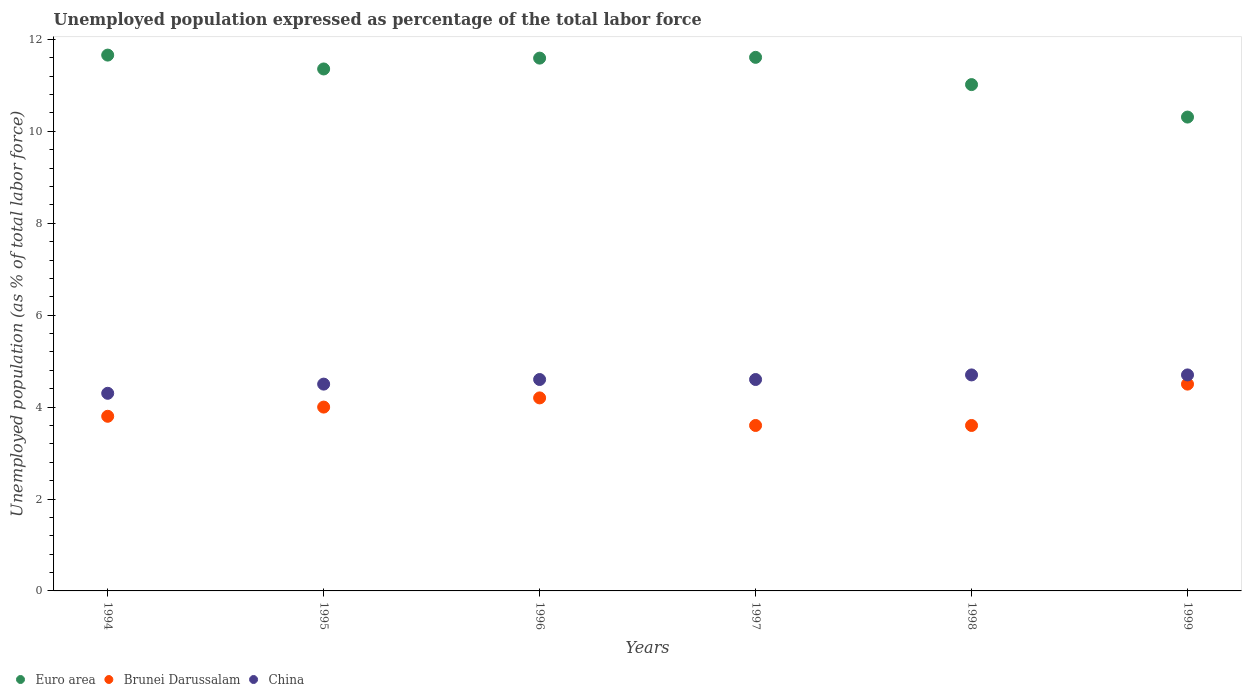How many different coloured dotlines are there?
Your response must be concise. 3. Is the number of dotlines equal to the number of legend labels?
Your answer should be compact. Yes. What is the unemployment in in Euro area in 1999?
Your response must be concise. 10.31. Across all years, what is the minimum unemployment in in Euro area?
Offer a terse response. 10.31. In which year was the unemployment in in Euro area maximum?
Offer a terse response. 1994. What is the total unemployment in in Brunei Darussalam in the graph?
Your answer should be compact. 23.7. What is the difference between the unemployment in in Euro area in 1994 and that in 1999?
Make the answer very short. 1.35. What is the difference between the unemployment in in China in 1995 and the unemployment in in Brunei Darussalam in 1997?
Give a very brief answer. 0.9. What is the average unemployment in in Euro area per year?
Your response must be concise. 11.26. In how many years, is the unemployment in in Euro area greater than 1.6 %?
Make the answer very short. 6. What is the ratio of the unemployment in in Euro area in 1996 to that in 1997?
Provide a succinct answer. 1. Is the unemployment in in Euro area in 1994 less than that in 1996?
Ensure brevity in your answer.  No. Is the difference between the unemployment in in Brunei Darussalam in 1995 and 1996 greater than the difference between the unemployment in in China in 1995 and 1996?
Ensure brevity in your answer.  No. What is the difference between the highest and the second highest unemployment in in Euro area?
Give a very brief answer. 0.05. What is the difference between the highest and the lowest unemployment in in Brunei Darussalam?
Keep it short and to the point. 0.9. In how many years, is the unemployment in in Brunei Darussalam greater than the average unemployment in in Brunei Darussalam taken over all years?
Your response must be concise. 3. Is the sum of the unemployment in in China in 1994 and 1995 greater than the maximum unemployment in in Brunei Darussalam across all years?
Your answer should be compact. Yes. Is it the case that in every year, the sum of the unemployment in in Euro area and unemployment in in China  is greater than the unemployment in in Brunei Darussalam?
Your answer should be compact. Yes. Does the unemployment in in China monotonically increase over the years?
Offer a terse response. No. How many years are there in the graph?
Your response must be concise. 6. Does the graph contain grids?
Ensure brevity in your answer.  No. Where does the legend appear in the graph?
Keep it short and to the point. Bottom left. How many legend labels are there?
Keep it short and to the point. 3. What is the title of the graph?
Your answer should be very brief. Unemployed population expressed as percentage of the total labor force. What is the label or title of the X-axis?
Offer a terse response. Years. What is the label or title of the Y-axis?
Provide a succinct answer. Unemployed population (as % of total labor force). What is the Unemployed population (as % of total labor force) in Euro area in 1994?
Provide a succinct answer. 11.66. What is the Unemployed population (as % of total labor force) of Brunei Darussalam in 1994?
Keep it short and to the point. 3.8. What is the Unemployed population (as % of total labor force) in China in 1994?
Make the answer very short. 4.3. What is the Unemployed population (as % of total labor force) of Euro area in 1995?
Your answer should be compact. 11.36. What is the Unemployed population (as % of total labor force) in Brunei Darussalam in 1995?
Offer a terse response. 4. What is the Unemployed population (as % of total labor force) in Euro area in 1996?
Provide a succinct answer. 11.59. What is the Unemployed population (as % of total labor force) of Brunei Darussalam in 1996?
Your answer should be compact. 4.2. What is the Unemployed population (as % of total labor force) of China in 1996?
Offer a very short reply. 4.6. What is the Unemployed population (as % of total labor force) of Euro area in 1997?
Make the answer very short. 11.61. What is the Unemployed population (as % of total labor force) in Brunei Darussalam in 1997?
Provide a short and direct response. 3.6. What is the Unemployed population (as % of total labor force) in China in 1997?
Make the answer very short. 4.6. What is the Unemployed population (as % of total labor force) in Euro area in 1998?
Ensure brevity in your answer.  11.02. What is the Unemployed population (as % of total labor force) of Brunei Darussalam in 1998?
Give a very brief answer. 3.6. What is the Unemployed population (as % of total labor force) in China in 1998?
Your answer should be compact. 4.7. What is the Unemployed population (as % of total labor force) of Euro area in 1999?
Keep it short and to the point. 10.31. What is the Unemployed population (as % of total labor force) of Brunei Darussalam in 1999?
Your answer should be very brief. 4.5. What is the Unemployed population (as % of total labor force) of China in 1999?
Offer a very short reply. 4.7. Across all years, what is the maximum Unemployed population (as % of total labor force) in Euro area?
Ensure brevity in your answer.  11.66. Across all years, what is the maximum Unemployed population (as % of total labor force) of Brunei Darussalam?
Offer a very short reply. 4.5. Across all years, what is the maximum Unemployed population (as % of total labor force) of China?
Your answer should be compact. 4.7. Across all years, what is the minimum Unemployed population (as % of total labor force) in Euro area?
Ensure brevity in your answer.  10.31. Across all years, what is the minimum Unemployed population (as % of total labor force) of Brunei Darussalam?
Keep it short and to the point. 3.6. Across all years, what is the minimum Unemployed population (as % of total labor force) in China?
Provide a succinct answer. 4.3. What is the total Unemployed population (as % of total labor force) of Euro area in the graph?
Provide a succinct answer. 67.55. What is the total Unemployed population (as % of total labor force) in Brunei Darussalam in the graph?
Your answer should be very brief. 23.7. What is the total Unemployed population (as % of total labor force) of China in the graph?
Offer a very short reply. 27.4. What is the difference between the Unemployed population (as % of total labor force) of Euro area in 1994 and that in 1995?
Your answer should be compact. 0.3. What is the difference between the Unemployed population (as % of total labor force) of Brunei Darussalam in 1994 and that in 1995?
Keep it short and to the point. -0.2. What is the difference between the Unemployed population (as % of total labor force) of China in 1994 and that in 1995?
Make the answer very short. -0.2. What is the difference between the Unemployed population (as % of total labor force) of Euro area in 1994 and that in 1996?
Provide a short and direct response. 0.07. What is the difference between the Unemployed population (as % of total labor force) in Brunei Darussalam in 1994 and that in 1996?
Provide a succinct answer. -0.4. What is the difference between the Unemployed population (as % of total labor force) in China in 1994 and that in 1996?
Keep it short and to the point. -0.3. What is the difference between the Unemployed population (as % of total labor force) in Euro area in 1994 and that in 1997?
Make the answer very short. 0.05. What is the difference between the Unemployed population (as % of total labor force) of Brunei Darussalam in 1994 and that in 1997?
Your answer should be compact. 0.2. What is the difference between the Unemployed population (as % of total labor force) of China in 1994 and that in 1997?
Your answer should be compact. -0.3. What is the difference between the Unemployed population (as % of total labor force) of Euro area in 1994 and that in 1998?
Make the answer very short. 0.64. What is the difference between the Unemployed population (as % of total labor force) of Brunei Darussalam in 1994 and that in 1998?
Keep it short and to the point. 0.2. What is the difference between the Unemployed population (as % of total labor force) in Euro area in 1994 and that in 1999?
Provide a short and direct response. 1.35. What is the difference between the Unemployed population (as % of total labor force) in Euro area in 1995 and that in 1996?
Offer a very short reply. -0.24. What is the difference between the Unemployed population (as % of total labor force) of Brunei Darussalam in 1995 and that in 1996?
Provide a succinct answer. -0.2. What is the difference between the Unemployed population (as % of total labor force) of China in 1995 and that in 1996?
Keep it short and to the point. -0.1. What is the difference between the Unemployed population (as % of total labor force) of Euro area in 1995 and that in 1997?
Provide a short and direct response. -0.25. What is the difference between the Unemployed population (as % of total labor force) in Brunei Darussalam in 1995 and that in 1997?
Ensure brevity in your answer.  0.4. What is the difference between the Unemployed population (as % of total labor force) of China in 1995 and that in 1997?
Make the answer very short. -0.1. What is the difference between the Unemployed population (as % of total labor force) of Euro area in 1995 and that in 1998?
Your answer should be very brief. 0.34. What is the difference between the Unemployed population (as % of total labor force) in China in 1995 and that in 1998?
Give a very brief answer. -0.2. What is the difference between the Unemployed population (as % of total labor force) in Euro area in 1995 and that in 1999?
Ensure brevity in your answer.  1.05. What is the difference between the Unemployed population (as % of total labor force) of Brunei Darussalam in 1995 and that in 1999?
Offer a terse response. -0.5. What is the difference between the Unemployed population (as % of total labor force) in China in 1995 and that in 1999?
Provide a succinct answer. -0.2. What is the difference between the Unemployed population (as % of total labor force) in Euro area in 1996 and that in 1997?
Give a very brief answer. -0.02. What is the difference between the Unemployed population (as % of total labor force) of Euro area in 1996 and that in 1998?
Provide a short and direct response. 0.58. What is the difference between the Unemployed population (as % of total labor force) in China in 1996 and that in 1998?
Your answer should be very brief. -0.1. What is the difference between the Unemployed population (as % of total labor force) in Euro area in 1996 and that in 1999?
Give a very brief answer. 1.28. What is the difference between the Unemployed population (as % of total labor force) in Brunei Darussalam in 1996 and that in 1999?
Provide a succinct answer. -0.3. What is the difference between the Unemployed population (as % of total labor force) in China in 1996 and that in 1999?
Offer a terse response. -0.1. What is the difference between the Unemployed population (as % of total labor force) in Euro area in 1997 and that in 1998?
Ensure brevity in your answer.  0.59. What is the difference between the Unemployed population (as % of total labor force) of China in 1997 and that in 1998?
Your response must be concise. -0.1. What is the difference between the Unemployed population (as % of total labor force) in Euro area in 1997 and that in 1999?
Your answer should be compact. 1.3. What is the difference between the Unemployed population (as % of total labor force) of Brunei Darussalam in 1997 and that in 1999?
Keep it short and to the point. -0.9. What is the difference between the Unemployed population (as % of total labor force) in Euro area in 1998 and that in 1999?
Offer a very short reply. 0.71. What is the difference between the Unemployed population (as % of total labor force) in Brunei Darussalam in 1998 and that in 1999?
Offer a terse response. -0.9. What is the difference between the Unemployed population (as % of total labor force) in China in 1998 and that in 1999?
Provide a short and direct response. 0. What is the difference between the Unemployed population (as % of total labor force) in Euro area in 1994 and the Unemployed population (as % of total labor force) in Brunei Darussalam in 1995?
Offer a very short reply. 7.66. What is the difference between the Unemployed population (as % of total labor force) of Euro area in 1994 and the Unemployed population (as % of total labor force) of China in 1995?
Your response must be concise. 7.16. What is the difference between the Unemployed population (as % of total labor force) of Brunei Darussalam in 1994 and the Unemployed population (as % of total labor force) of China in 1995?
Ensure brevity in your answer.  -0.7. What is the difference between the Unemployed population (as % of total labor force) of Euro area in 1994 and the Unemployed population (as % of total labor force) of Brunei Darussalam in 1996?
Offer a terse response. 7.46. What is the difference between the Unemployed population (as % of total labor force) in Euro area in 1994 and the Unemployed population (as % of total labor force) in China in 1996?
Provide a short and direct response. 7.06. What is the difference between the Unemployed population (as % of total labor force) in Euro area in 1994 and the Unemployed population (as % of total labor force) in Brunei Darussalam in 1997?
Provide a short and direct response. 8.06. What is the difference between the Unemployed population (as % of total labor force) in Euro area in 1994 and the Unemployed population (as % of total labor force) in China in 1997?
Give a very brief answer. 7.06. What is the difference between the Unemployed population (as % of total labor force) in Brunei Darussalam in 1994 and the Unemployed population (as % of total labor force) in China in 1997?
Make the answer very short. -0.8. What is the difference between the Unemployed population (as % of total labor force) of Euro area in 1994 and the Unemployed population (as % of total labor force) of Brunei Darussalam in 1998?
Make the answer very short. 8.06. What is the difference between the Unemployed population (as % of total labor force) of Euro area in 1994 and the Unemployed population (as % of total labor force) of China in 1998?
Provide a succinct answer. 6.96. What is the difference between the Unemployed population (as % of total labor force) in Brunei Darussalam in 1994 and the Unemployed population (as % of total labor force) in China in 1998?
Provide a succinct answer. -0.9. What is the difference between the Unemployed population (as % of total labor force) of Euro area in 1994 and the Unemployed population (as % of total labor force) of Brunei Darussalam in 1999?
Your answer should be very brief. 7.16. What is the difference between the Unemployed population (as % of total labor force) in Euro area in 1994 and the Unemployed population (as % of total labor force) in China in 1999?
Offer a terse response. 6.96. What is the difference between the Unemployed population (as % of total labor force) of Euro area in 1995 and the Unemployed population (as % of total labor force) of Brunei Darussalam in 1996?
Offer a terse response. 7.16. What is the difference between the Unemployed population (as % of total labor force) in Euro area in 1995 and the Unemployed population (as % of total labor force) in China in 1996?
Provide a succinct answer. 6.76. What is the difference between the Unemployed population (as % of total labor force) of Euro area in 1995 and the Unemployed population (as % of total labor force) of Brunei Darussalam in 1997?
Make the answer very short. 7.76. What is the difference between the Unemployed population (as % of total labor force) of Euro area in 1995 and the Unemployed population (as % of total labor force) of China in 1997?
Give a very brief answer. 6.76. What is the difference between the Unemployed population (as % of total labor force) in Euro area in 1995 and the Unemployed population (as % of total labor force) in Brunei Darussalam in 1998?
Provide a succinct answer. 7.76. What is the difference between the Unemployed population (as % of total labor force) in Euro area in 1995 and the Unemployed population (as % of total labor force) in China in 1998?
Keep it short and to the point. 6.66. What is the difference between the Unemployed population (as % of total labor force) in Brunei Darussalam in 1995 and the Unemployed population (as % of total labor force) in China in 1998?
Keep it short and to the point. -0.7. What is the difference between the Unemployed population (as % of total labor force) in Euro area in 1995 and the Unemployed population (as % of total labor force) in Brunei Darussalam in 1999?
Your answer should be compact. 6.86. What is the difference between the Unemployed population (as % of total labor force) in Euro area in 1995 and the Unemployed population (as % of total labor force) in China in 1999?
Your response must be concise. 6.66. What is the difference between the Unemployed population (as % of total labor force) of Brunei Darussalam in 1995 and the Unemployed population (as % of total labor force) of China in 1999?
Give a very brief answer. -0.7. What is the difference between the Unemployed population (as % of total labor force) in Euro area in 1996 and the Unemployed population (as % of total labor force) in Brunei Darussalam in 1997?
Provide a succinct answer. 7.99. What is the difference between the Unemployed population (as % of total labor force) of Euro area in 1996 and the Unemployed population (as % of total labor force) of China in 1997?
Your answer should be compact. 6.99. What is the difference between the Unemployed population (as % of total labor force) in Euro area in 1996 and the Unemployed population (as % of total labor force) in Brunei Darussalam in 1998?
Offer a terse response. 7.99. What is the difference between the Unemployed population (as % of total labor force) of Euro area in 1996 and the Unemployed population (as % of total labor force) of China in 1998?
Provide a short and direct response. 6.89. What is the difference between the Unemployed population (as % of total labor force) of Euro area in 1996 and the Unemployed population (as % of total labor force) of Brunei Darussalam in 1999?
Keep it short and to the point. 7.09. What is the difference between the Unemployed population (as % of total labor force) in Euro area in 1996 and the Unemployed population (as % of total labor force) in China in 1999?
Make the answer very short. 6.89. What is the difference between the Unemployed population (as % of total labor force) in Brunei Darussalam in 1996 and the Unemployed population (as % of total labor force) in China in 1999?
Keep it short and to the point. -0.5. What is the difference between the Unemployed population (as % of total labor force) in Euro area in 1997 and the Unemployed population (as % of total labor force) in Brunei Darussalam in 1998?
Offer a terse response. 8.01. What is the difference between the Unemployed population (as % of total labor force) in Euro area in 1997 and the Unemployed population (as % of total labor force) in China in 1998?
Provide a short and direct response. 6.91. What is the difference between the Unemployed population (as % of total labor force) in Brunei Darussalam in 1997 and the Unemployed population (as % of total labor force) in China in 1998?
Provide a succinct answer. -1.1. What is the difference between the Unemployed population (as % of total labor force) of Euro area in 1997 and the Unemployed population (as % of total labor force) of Brunei Darussalam in 1999?
Offer a very short reply. 7.11. What is the difference between the Unemployed population (as % of total labor force) of Euro area in 1997 and the Unemployed population (as % of total labor force) of China in 1999?
Provide a succinct answer. 6.91. What is the difference between the Unemployed population (as % of total labor force) in Euro area in 1998 and the Unemployed population (as % of total labor force) in Brunei Darussalam in 1999?
Offer a terse response. 6.52. What is the difference between the Unemployed population (as % of total labor force) in Euro area in 1998 and the Unemployed population (as % of total labor force) in China in 1999?
Provide a succinct answer. 6.32. What is the difference between the Unemployed population (as % of total labor force) in Brunei Darussalam in 1998 and the Unemployed population (as % of total labor force) in China in 1999?
Make the answer very short. -1.1. What is the average Unemployed population (as % of total labor force) of Euro area per year?
Offer a very short reply. 11.26. What is the average Unemployed population (as % of total labor force) in Brunei Darussalam per year?
Your answer should be compact. 3.95. What is the average Unemployed population (as % of total labor force) of China per year?
Provide a succinct answer. 4.57. In the year 1994, what is the difference between the Unemployed population (as % of total labor force) in Euro area and Unemployed population (as % of total labor force) in Brunei Darussalam?
Provide a short and direct response. 7.86. In the year 1994, what is the difference between the Unemployed population (as % of total labor force) of Euro area and Unemployed population (as % of total labor force) of China?
Offer a very short reply. 7.36. In the year 1994, what is the difference between the Unemployed population (as % of total labor force) in Brunei Darussalam and Unemployed population (as % of total labor force) in China?
Your response must be concise. -0.5. In the year 1995, what is the difference between the Unemployed population (as % of total labor force) in Euro area and Unemployed population (as % of total labor force) in Brunei Darussalam?
Offer a very short reply. 7.36. In the year 1995, what is the difference between the Unemployed population (as % of total labor force) of Euro area and Unemployed population (as % of total labor force) of China?
Keep it short and to the point. 6.86. In the year 1996, what is the difference between the Unemployed population (as % of total labor force) in Euro area and Unemployed population (as % of total labor force) in Brunei Darussalam?
Your answer should be compact. 7.39. In the year 1996, what is the difference between the Unemployed population (as % of total labor force) in Euro area and Unemployed population (as % of total labor force) in China?
Keep it short and to the point. 6.99. In the year 1997, what is the difference between the Unemployed population (as % of total labor force) in Euro area and Unemployed population (as % of total labor force) in Brunei Darussalam?
Give a very brief answer. 8.01. In the year 1997, what is the difference between the Unemployed population (as % of total labor force) of Euro area and Unemployed population (as % of total labor force) of China?
Make the answer very short. 7.01. In the year 1997, what is the difference between the Unemployed population (as % of total labor force) in Brunei Darussalam and Unemployed population (as % of total labor force) in China?
Your response must be concise. -1. In the year 1998, what is the difference between the Unemployed population (as % of total labor force) in Euro area and Unemployed population (as % of total labor force) in Brunei Darussalam?
Keep it short and to the point. 7.42. In the year 1998, what is the difference between the Unemployed population (as % of total labor force) in Euro area and Unemployed population (as % of total labor force) in China?
Give a very brief answer. 6.32. In the year 1999, what is the difference between the Unemployed population (as % of total labor force) in Euro area and Unemployed population (as % of total labor force) in Brunei Darussalam?
Offer a terse response. 5.81. In the year 1999, what is the difference between the Unemployed population (as % of total labor force) in Euro area and Unemployed population (as % of total labor force) in China?
Your answer should be very brief. 5.61. What is the ratio of the Unemployed population (as % of total labor force) in Euro area in 1994 to that in 1995?
Make the answer very short. 1.03. What is the ratio of the Unemployed population (as % of total labor force) in China in 1994 to that in 1995?
Provide a short and direct response. 0.96. What is the ratio of the Unemployed population (as % of total labor force) in Euro area in 1994 to that in 1996?
Make the answer very short. 1.01. What is the ratio of the Unemployed population (as % of total labor force) of Brunei Darussalam in 1994 to that in 1996?
Your answer should be compact. 0.9. What is the ratio of the Unemployed population (as % of total labor force) of China in 1994 to that in 1996?
Provide a succinct answer. 0.93. What is the ratio of the Unemployed population (as % of total labor force) of Euro area in 1994 to that in 1997?
Your response must be concise. 1. What is the ratio of the Unemployed population (as % of total labor force) in Brunei Darussalam in 1994 to that in 1997?
Provide a short and direct response. 1.06. What is the ratio of the Unemployed population (as % of total labor force) in China in 1994 to that in 1997?
Your answer should be compact. 0.93. What is the ratio of the Unemployed population (as % of total labor force) of Euro area in 1994 to that in 1998?
Provide a short and direct response. 1.06. What is the ratio of the Unemployed population (as % of total labor force) of Brunei Darussalam in 1994 to that in 1998?
Your answer should be compact. 1.06. What is the ratio of the Unemployed population (as % of total labor force) in China in 1994 to that in 1998?
Make the answer very short. 0.91. What is the ratio of the Unemployed population (as % of total labor force) in Euro area in 1994 to that in 1999?
Give a very brief answer. 1.13. What is the ratio of the Unemployed population (as % of total labor force) in Brunei Darussalam in 1994 to that in 1999?
Provide a succinct answer. 0.84. What is the ratio of the Unemployed population (as % of total labor force) of China in 1994 to that in 1999?
Ensure brevity in your answer.  0.91. What is the ratio of the Unemployed population (as % of total labor force) of Euro area in 1995 to that in 1996?
Your answer should be compact. 0.98. What is the ratio of the Unemployed population (as % of total labor force) in China in 1995 to that in 1996?
Ensure brevity in your answer.  0.98. What is the ratio of the Unemployed population (as % of total labor force) in Euro area in 1995 to that in 1997?
Offer a terse response. 0.98. What is the ratio of the Unemployed population (as % of total labor force) of Brunei Darussalam in 1995 to that in 1997?
Give a very brief answer. 1.11. What is the ratio of the Unemployed population (as % of total labor force) of China in 1995 to that in 1997?
Provide a succinct answer. 0.98. What is the ratio of the Unemployed population (as % of total labor force) of Euro area in 1995 to that in 1998?
Keep it short and to the point. 1.03. What is the ratio of the Unemployed population (as % of total labor force) in Brunei Darussalam in 1995 to that in 1998?
Your answer should be compact. 1.11. What is the ratio of the Unemployed population (as % of total labor force) of China in 1995 to that in 1998?
Offer a terse response. 0.96. What is the ratio of the Unemployed population (as % of total labor force) of Euro area in 1995 to that in 1999?
Provide a succinct answer. 1.1. What is the ratio of the Unemployed population (as % of total labor force) in Brunei Darussalam in 1995 to that in 1999?
Make the answer very short. 0.89. What is the ratio of the Unemployed population (as % of total labor force) in China in 1995 to that in 1999?
Ensure brevity in your answer.  0.96. What is the ratio of the Unemployed population (as % of total labor force) of Brunei Darussalam in 1996 to that in 1997?
Keep it short and to the point. 1.17. What is the ratio of the Unemployed population (as % of total labor force) in Euro area in 1996 to that in 1998?
Keep it short and to the point. 1.05. What is the ratio of the Unemployed population (as % of total labor force) of China in 1996 to that in 1998?
Provide a succinct answer. 0.98. What is the ratio of the Unemployed population (as % of total labor force) of Euro area in 1996 to that in 1999?
Give a very brief answer. 1.12. What is the ratio of the Unemployed population (as % of total labor force) of China in 1996 to that in 1999?
Keep it short and to the point. 0.98. What is the ratio of the Unemployed population (as % of total labor force) of Euro area in 1997 to that in 1998?
Keep it short and to the point. 1.05. What is the ratio of the Unemployed population (as % of total labor force) of China in 1997 to that in 1998?
Your answer should be compact. 0.98. What is the ratio of the Unemployed population (as % of total labor force) in Euro area in 1997 to that in 1999?
Ensure brevity in your answer.  1.13. What is the ratio of the Unemployed population (as % of total labor force) of China in 1997 to that in 1999?
Provide a short and direct response. 0.98. What is the ratio of the Unemployed population (as % of total labor force) of Euro area in 1998 to that in 1999?
Your answer should be compact. 1.07. What is the ratio of the Unemployed population (as % of total labor force) of Brunei Darussalam in 1998 to that in 1999?
Provide a short and direct response. 0.8. What is the difference between the highest and the second highest Unemployed population (as % of total labor force) in Euro area?
Your answer should be very brief. 0.05. What is the difference between the highest and the second highest Unemployed population (as % of total labor force) of Brunei Darussalam?
Give a very brief answer. 0.3. What is the difference between the highest and the lowest Unemployed population (as % of total labor force) of Euro area?
Provide a short and direct response. 1.35. What is the difference between the highest and the lowest Unemployed population (as % of total labor force) of China?
Your response must be concise. 0.4. 